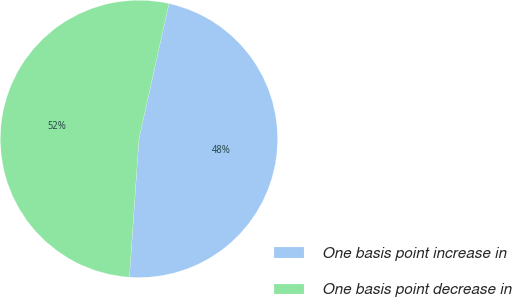Convert chart. <chart><loc_0><loc_0><loc_500><loc_500><pie_chart><fcel>One basis point increase in<fcel>One basis point decrease in<nl><fcel>47.62%<fcel>52.38%<nl></chart> 